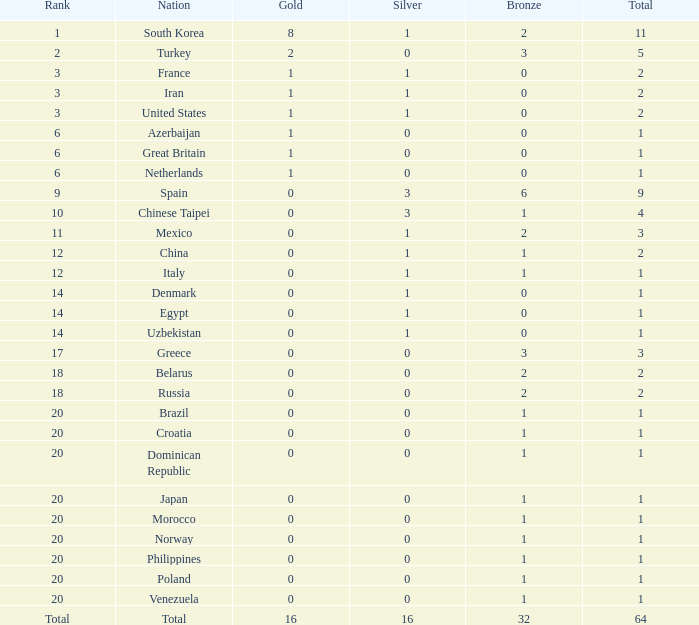What is the overall number of silvers for russia? 1.0. Parse the full table. {'header': ['Rank', 'Nation', 'Gold', 'Silver', 'Bronze', 'Total'], 'rows': [['1', 'South Korea', '8', '1', '2', '11'], ['2', 'Turkey', '2', '0', '3', '5'], ['3', 'France', '1', '1', '0', '2'], ['3', 'Iran', '1', '1', '0', '2'], ['3', 'United States', '1', '1', '0', '2'], ['6', 'Azerbaijan', '1', '0', '0', '1'], ['6', 'Great Britain', '1', '0', '0', '1'], ['6', 'Netherlands', '1', '0', '0', '1'], ['9', 'Spain', '0', '3', '6', '9'], ['10', 'Chinese Taipei', '0', '3', '1', '4'], ['11', 'Mexico', '0', '1', '2', '3'], ['12', 'China', '0', '1', '1', '2'], ['12', 'Italy', '0', '1', '1', '1'], ['14', 'Denmark', '0', '1', '0', '1'], ['14', 'Egypt', '0', '1', '0', '1'], ['14', 'Uzbekistan', '0', '1', '0', '1'], ['17', 'Greece', '0', '0', '3', '3'], ['18', 'Belarus', '0', '0', '2', '2'], ['18', 'Russia', '0', '0', '2', '2'], ['20', 'Brazil', '0', '0', '1', '1'], ['20', 'Croatia', '0', '0', '1', '1'], ['20', 'Dominican Republic', '0', '0', '1', '1'], ['20', 'Japan', '0', '0', '1', '1'], ['20', 'Morocco', '0', '0', '1', '1'], ['20', 'Norway', '0', '0', '1', '1'], ['20', 'Philippines', '0', '0', '1', '1'], ['20', 'Poland', '0', '0', '1', '1'], ['20', 'Venezuela', '0', '0', '1', '1'], ['Total', 'Total', '16', '16', '32', '64']]} 